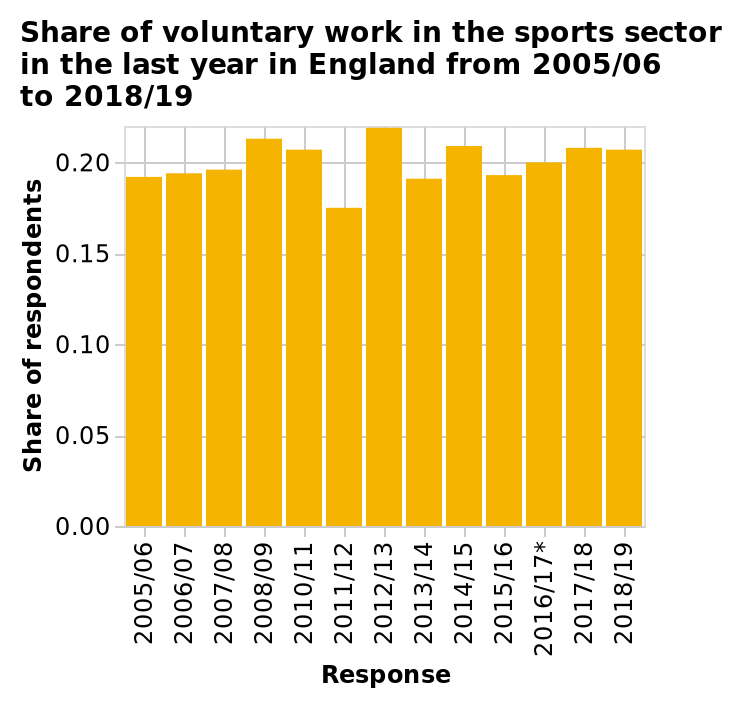<image>
please summary the statistics and relations of the chart I can see that 2005 until 2019 the volunteer  work has almost his the 0.20 mark. In the years 2011 until 2012 is the lowest time in the years studied. There isn’t much variation between all of the years. What is the minimum value on the y-axis? The minimum value on the y-axis is 0.00, indicating the lowest share of respondents in the sports sector. What was the trend in volunteer work from 2005 to 2019?  The trend in volunteer work from 2005 to 2019 was consistently low, almost hitting the 0.20 mark. Has the volunteer work surpassed the 0.20 mark from 2005 to 2019? No.I can see that 2005 until 2019 the volunteer  work has almost his the 0.20 mark. In the years 2011 until 2012 is the lowest time in the years studied. There isn’t much variation between all of the years. 